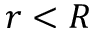<formula> <loc_0><loc_0><loc_500><loc_500>r < R</formula> 